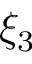Convert formula to latex. <formula><loc_0><loc_0><loc_500><loc_500>\xi _ { 3 }</formula> 